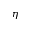Convert formula to latex. <formula><loc_0><loc_0><loc_500><loc_500>\eta</formula> 